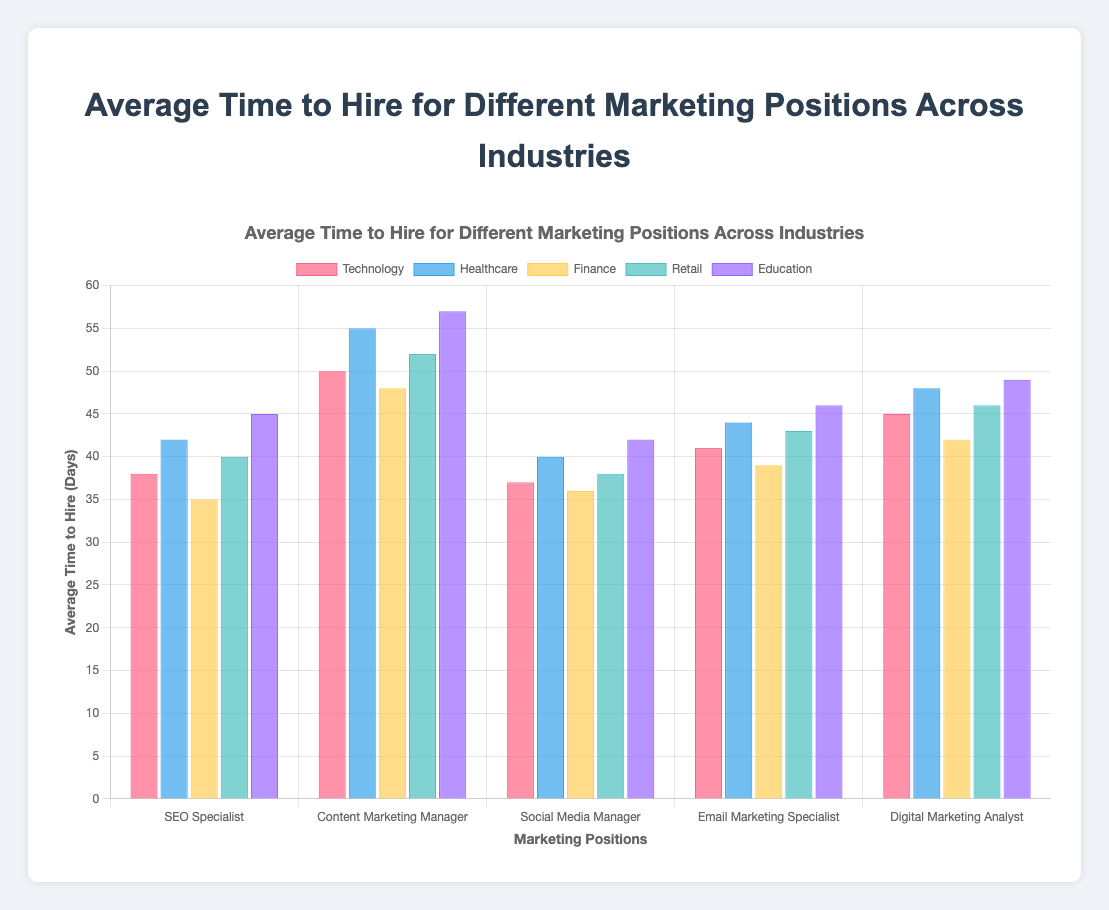Which industry has the longest average time to hire for an SEO Specialist? From the figure, look for the bar representing SEO Specialist across industries and identify the highest bar. The tallest bar for SEO Specialist is in Education.
Answer: Education Which marketing position has the fastest average time to hire in the Finance industry? Look at the bars for the Finance industry and identify the shortest one. The shortest bar in Finance is for the SEO Specialist.
Answer: SEO Specialist Compare the average time to hire for a Social Media Manager between Technology and Healthcare. Which is higher? Check the bars representing Social Media Manager for Technology and Healthcare. The bar for Healthcare is higher than for Technology.
Answer: Healthcare What is the total average time to hire for a Content Marketing Manager across all industries? Sum the values for Content Marketing Manager: 50 (Technology) + 55 (Healthcare) + 48 (Finance) + 52 (Retail) + 57 (Education) = 262.
Answer: 262 How much longer does it take, on average, to hire an Email Marketing Specialist in Education compared to Retail? Find the bars for Email Marketing Specialist in Education and Retail and calculate the difference: 46 (Education) - 43 (Retail) = 3.
Answer: 3 What is the average time to hire for Digital Marketing Analyst in Technology and Retail combined? Add the values for Digital Marketing Analyst in Technology and Retail and divide by 2: (45 + 46) / 2 = 45.5.
Answer: 45.5 Which industry has the most consistent average time to hire across all marketing positions? Compare the variations in bar heights for each industry across all positions. Retail shows less variation compared to others.
Answer: Retail For the Healthcare industry, rank the marketing positions from longest to shortest average time to hire. Reorder the bars for Healthcare from highest to lowest: Content Marketing Manager, Digital Marketing Analyst, Email Marketing Specialist, SEO Specialist, Social Media Manager.
Answer: Content Marketing Manager, Digital Marketing Analyst, Email Marketing Specialist, SEO Specialist, Social Media Manager Which marketing position has the smallest range of average time to hire values across all industries? Calculate the range (difference between the highest and lowest values) for each position: SEO Specialist (45-35=10), Content Marketing Manager (57-48=9), Social Media Manager (42-36=6), Email Marketing Specialist (46-39=7), Digital Marketing Analyst (49-42=7). The smallest range is for Social Media Manager (6).
Answer: Social Media Manager What is the overall highest average time to hire for any marketing position in a single industry? Check all bars to find the highest one. The highest bar is for Content Marketing Manager in Education at 57 days.
Answer: 57 